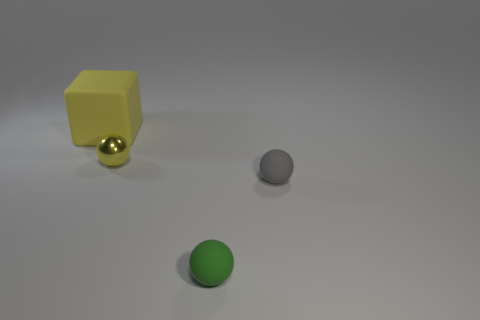Which object stands out the most, and why? The yellow cube stands out the most due to its bright color and geometric shape that contrasts with the round spheres and the neutral colors of the other objects and the background. What might the different textures of the objects suggest? The textures suggest different materials; the shiny golden sphere could be metallic, the matte grey sphere seems like stone or concrete, and the yellow cube, with its slightly less reflective surface, might be made of plastic or another non-metallic material. 